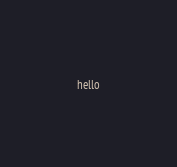Convert code to text. <code><loc_0><loc_0><loc_500><loc_500><_Scala_>hello
</code> 